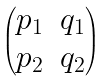Convert formula to latex. <formula><loc_0><loc_0><loc_500><loc_500>\begin{pmatrix} p _ { 1 } & q _ { 1 } \\ p _ { 2 } & q _ { 2 } \end{pmatrix}</formula> 